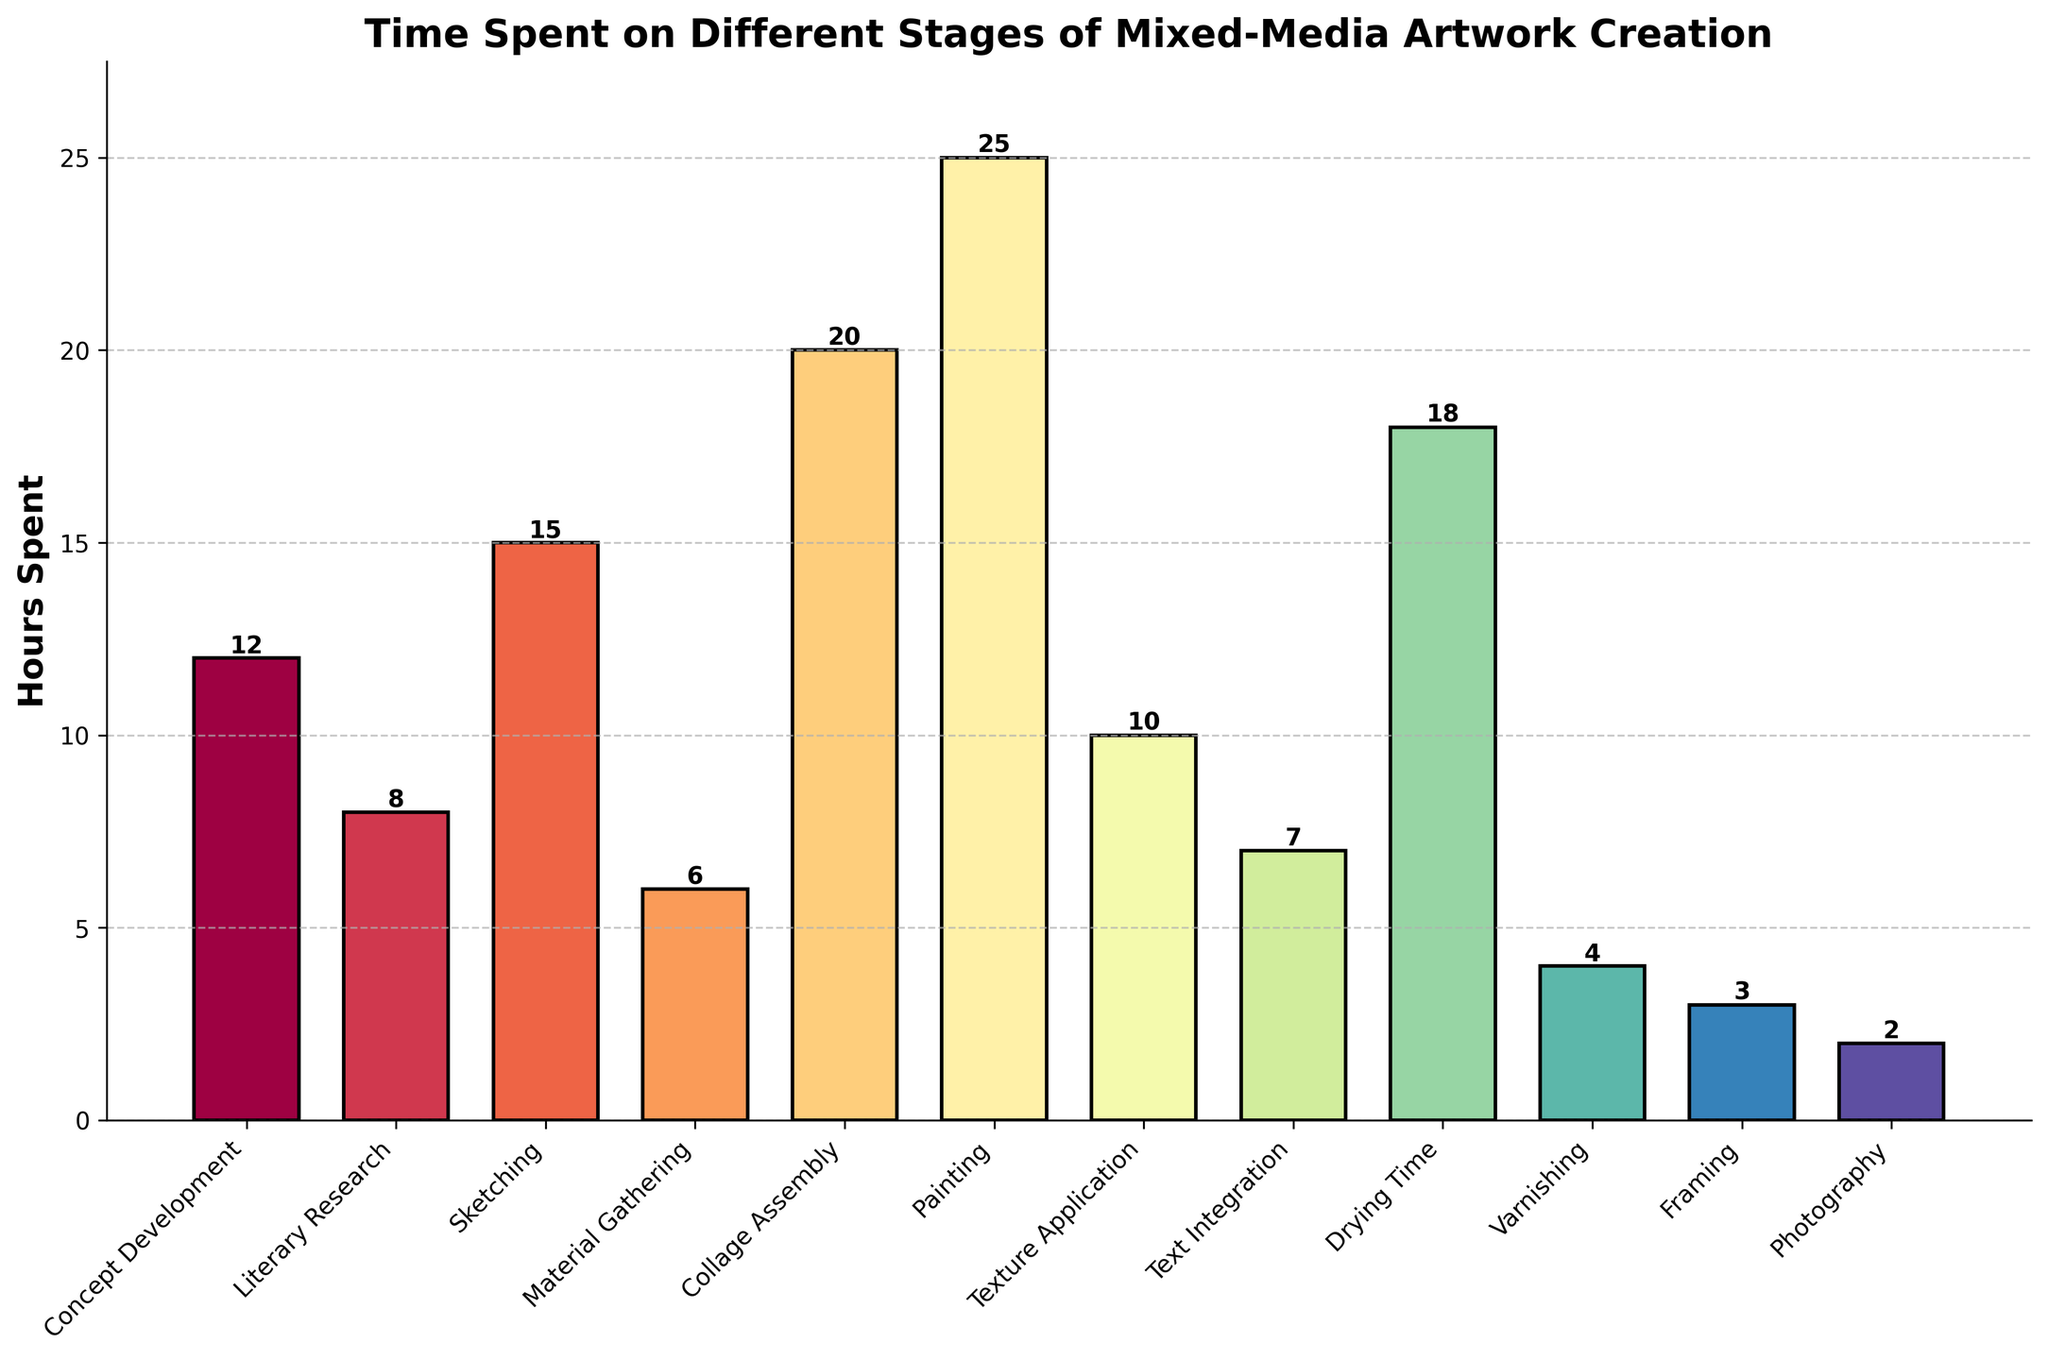Which stage takes the longest time? By visually comparing the height of each bar, we can see that the "Painting" stage has the tallest bar, which means it takes the longest time.
Answer: Painting Which stage takes the shortest time? By looking at the smallest bar on the chart, "Photography" has the shortest bar, indicating it takes the least amount of time.
Answer: Photography How much more time is spent on Painting compared to Sketching? The bar for Painting shows 25 hours, and the bar for Sketching shows 15 hours. The difference is 25 - 15 = 10 hours.
Answer: 10 hours What is the combined time spent on Concept Development and Literary Research? The bar for Concept Development shows 12 hours, and for Literary Research, it shows 8 hours. Adding them together: 12 + 8 = 20 hours.
Answer: 20 hours Which two stages have the closest time spent, and what is that time difference? By closely examining the bar heights, "Text Integration" (7 hours) and "Material Gathering" (6 hours) have the closest times with a difference of 7 - 6 = 1 hour.
Answer: Text Integration and Material Gathering, 1 hour What is the total time spent on tasks after the artwork is completed (e.g., Drying Time, Varnishing, Framing, Photography)? Adding the hours for Drying Time (18), Varnishing (4), Framing (3), and Photography (2): 18 + 4 + 3 + 2 = 27 hours.
Answer: 27 hours How much more time is spent on Collage Assembly compared to Texture Application? The bar for Collage Assembly shows 20 hours, and for Texture Application, it shows 10 hours. The difference is 20 - 10 = 10 hours.
Answer: 10 hours Which stage has the second most amount of time spent on average and what is that time? By observing the bar heights, the second tallest bar represents "Drying Time" with 18 hours.
Answer: Drying Time, 18 hours 